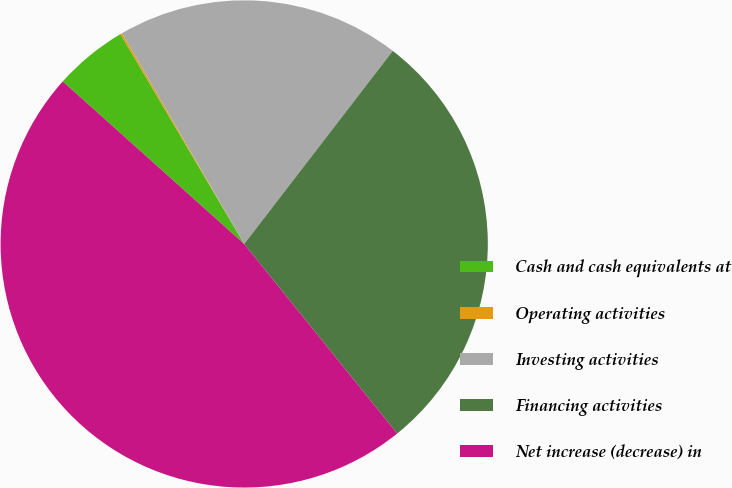Convert chart to OTSL. <chart><loc_0><loc_0><loc_500><loc_500><pie_chart><fcel>Cash and cash equivalents at<fcel>Operating activities<fcel>Investing activities<fcel>Financing activities<fcel>Net increase (decrease) in<nl><fcel>4.89%<fcel>0.12%<fcel>18.8%<fcel>28.75%<fcel>47.43%<nl></chart> 